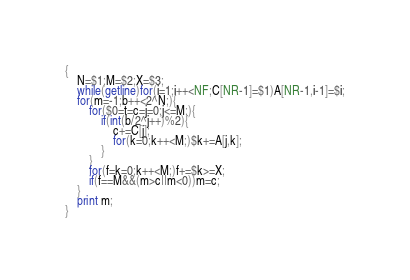<code> <loc_0><loc_0><loc_500><loc_500><_Awk_>{
    N=$1;M=$2;X=$3;
    while(getline)for(i=1;i++<NF;C[NR-1]=$1)A[NR-1,i-1]=$i;
    for(m=-1;b++<2^N;){
        for($0=t=c=j=0;j<=M;){
            if(int(b/2^j++)%2){
                c+=C[j];
                for(k=0;k++<M;)$k+=A[j,k];
            }
        }
        for(f=k=0;k++<M;)f+=$k>=X;
        if(f==M&&(m>c||m<0))m=c;
    }
    print m;
}</code> 